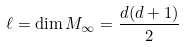<formula> <loc_0><loc_0><loc_500><loc_500>\ell = \dim M _ { \infty } = \frac { d ( d + 1 ) } { 2 }</formula> 